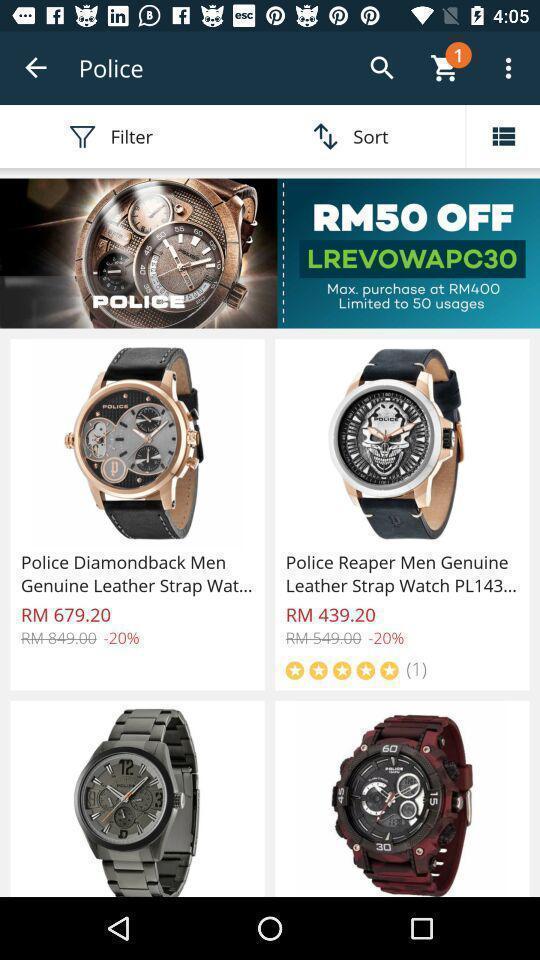Summarize the main components in this picture. Page showing all the products. 